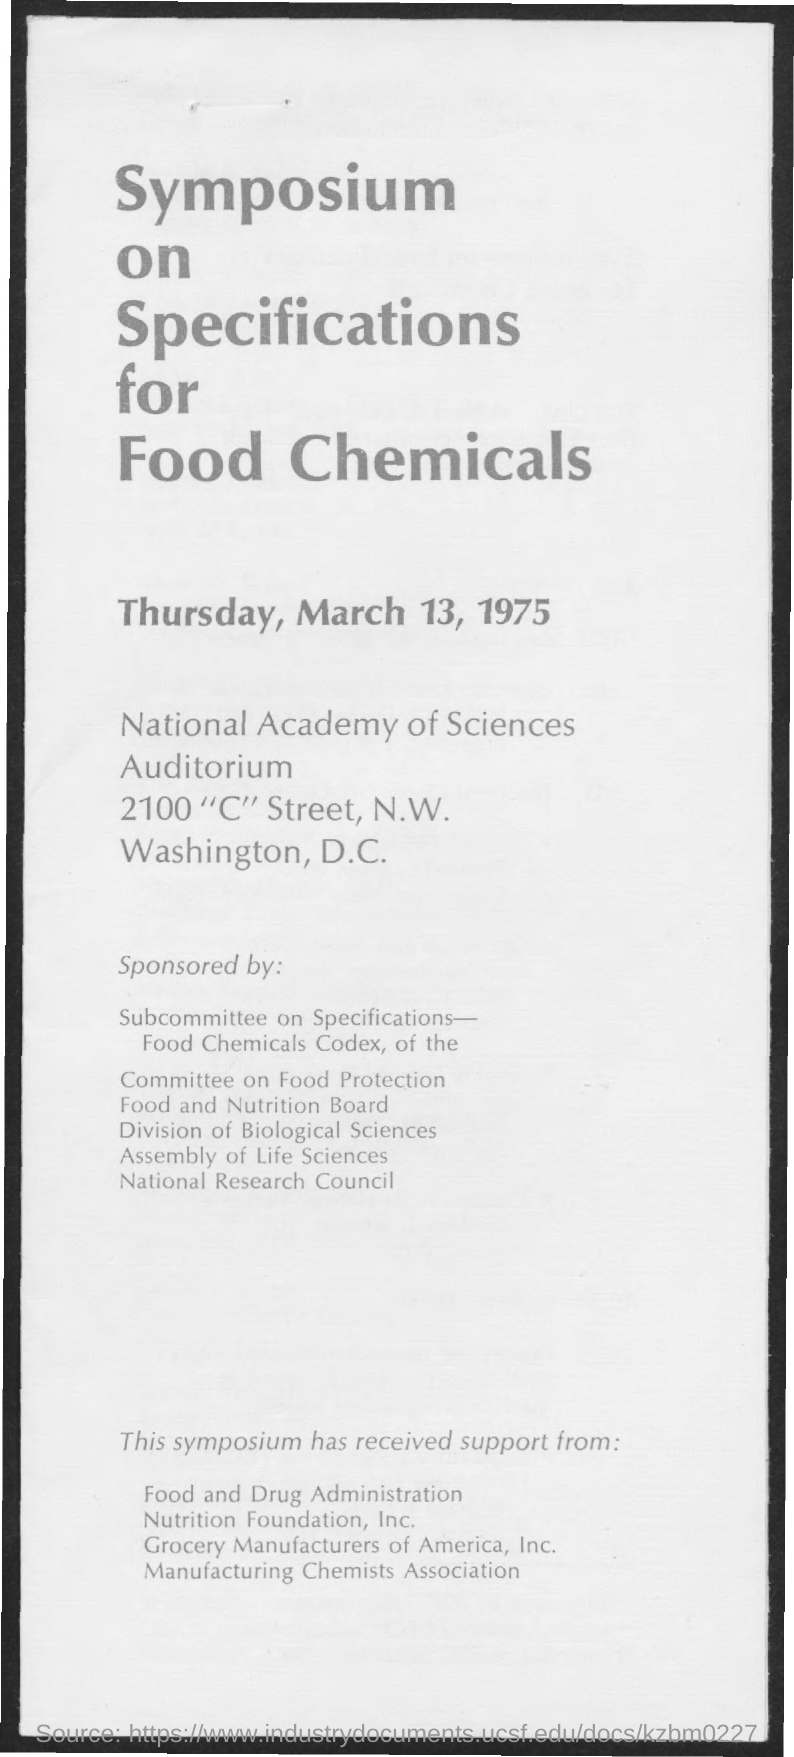When was the Symposium on Specifications for Food Chemicals held?
Provide a succinct answer. Thursday, March 13, 1975. 